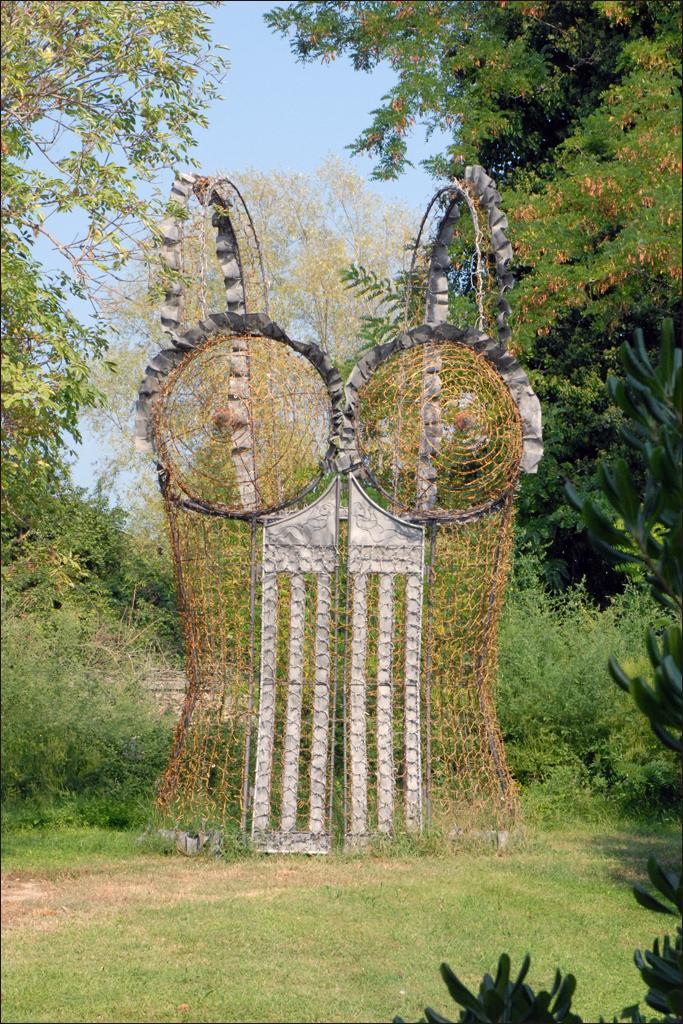Can you describe this image briefly? In this image in the center there is an arch, and on the right side and left side of the image there are trees and plants. At the bottom there is grass and plants, and at the top there is sky. 